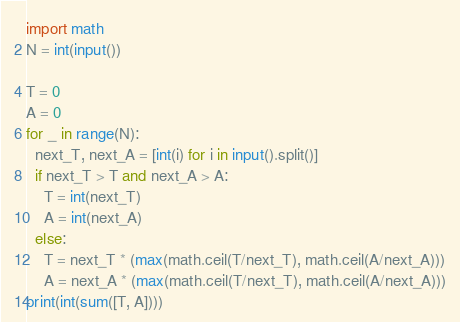<code> <loc_0><loc_0><loc_500><loc_500><_Python_>import math
N = int(input())

T = 0
A = 0
for _ in range(N):
  next_T, next_A = [int(i) for i in input().split()]
  if next_T > T and next_A > A:
    T = int(next_T)
    A = int(next_A)
  else: 
    T = next_T * (max(math.ceil(T/next_T), math.ceil(A/next_A)))
    A = next_A * (max(math.ceil(T/next_T), math.ceil(A/next_A)))
print(int(sum([T, A])))</code> 